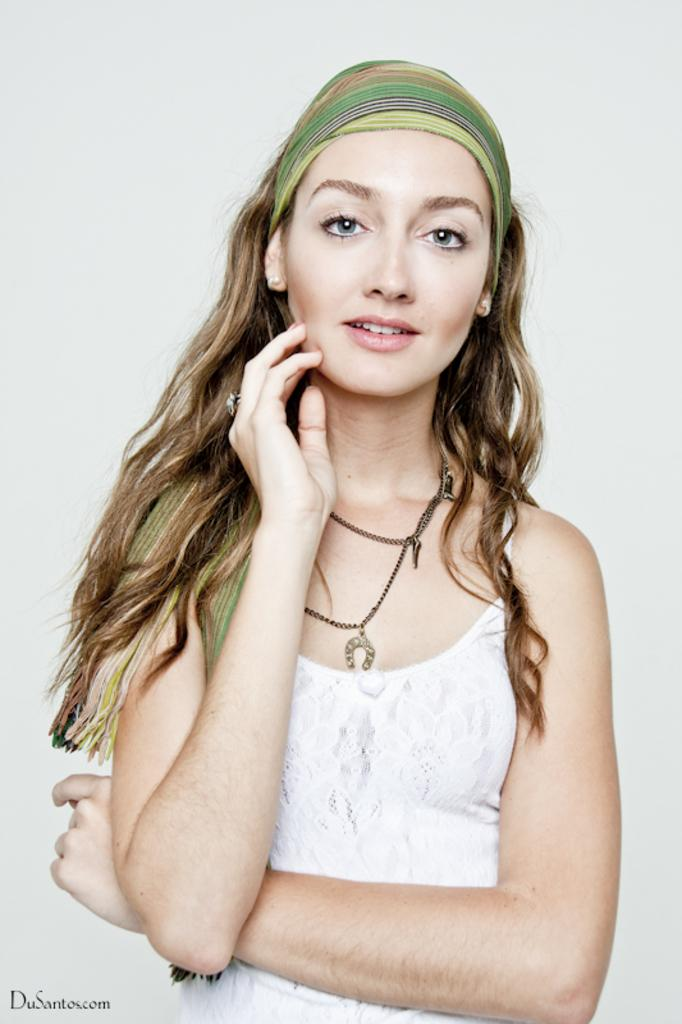Who or what is present in the image? There is a person in the image. What is the person doing or expressing? The person is smiling. What is behind the person in the image? There is a wall behind the person. What can be seen on the left side of the image? There is some text on the left side of the image. What type of beast can be seen crawling on the wall in the image? There is no beast present in the image; it only features a person, a wall, and some text. 